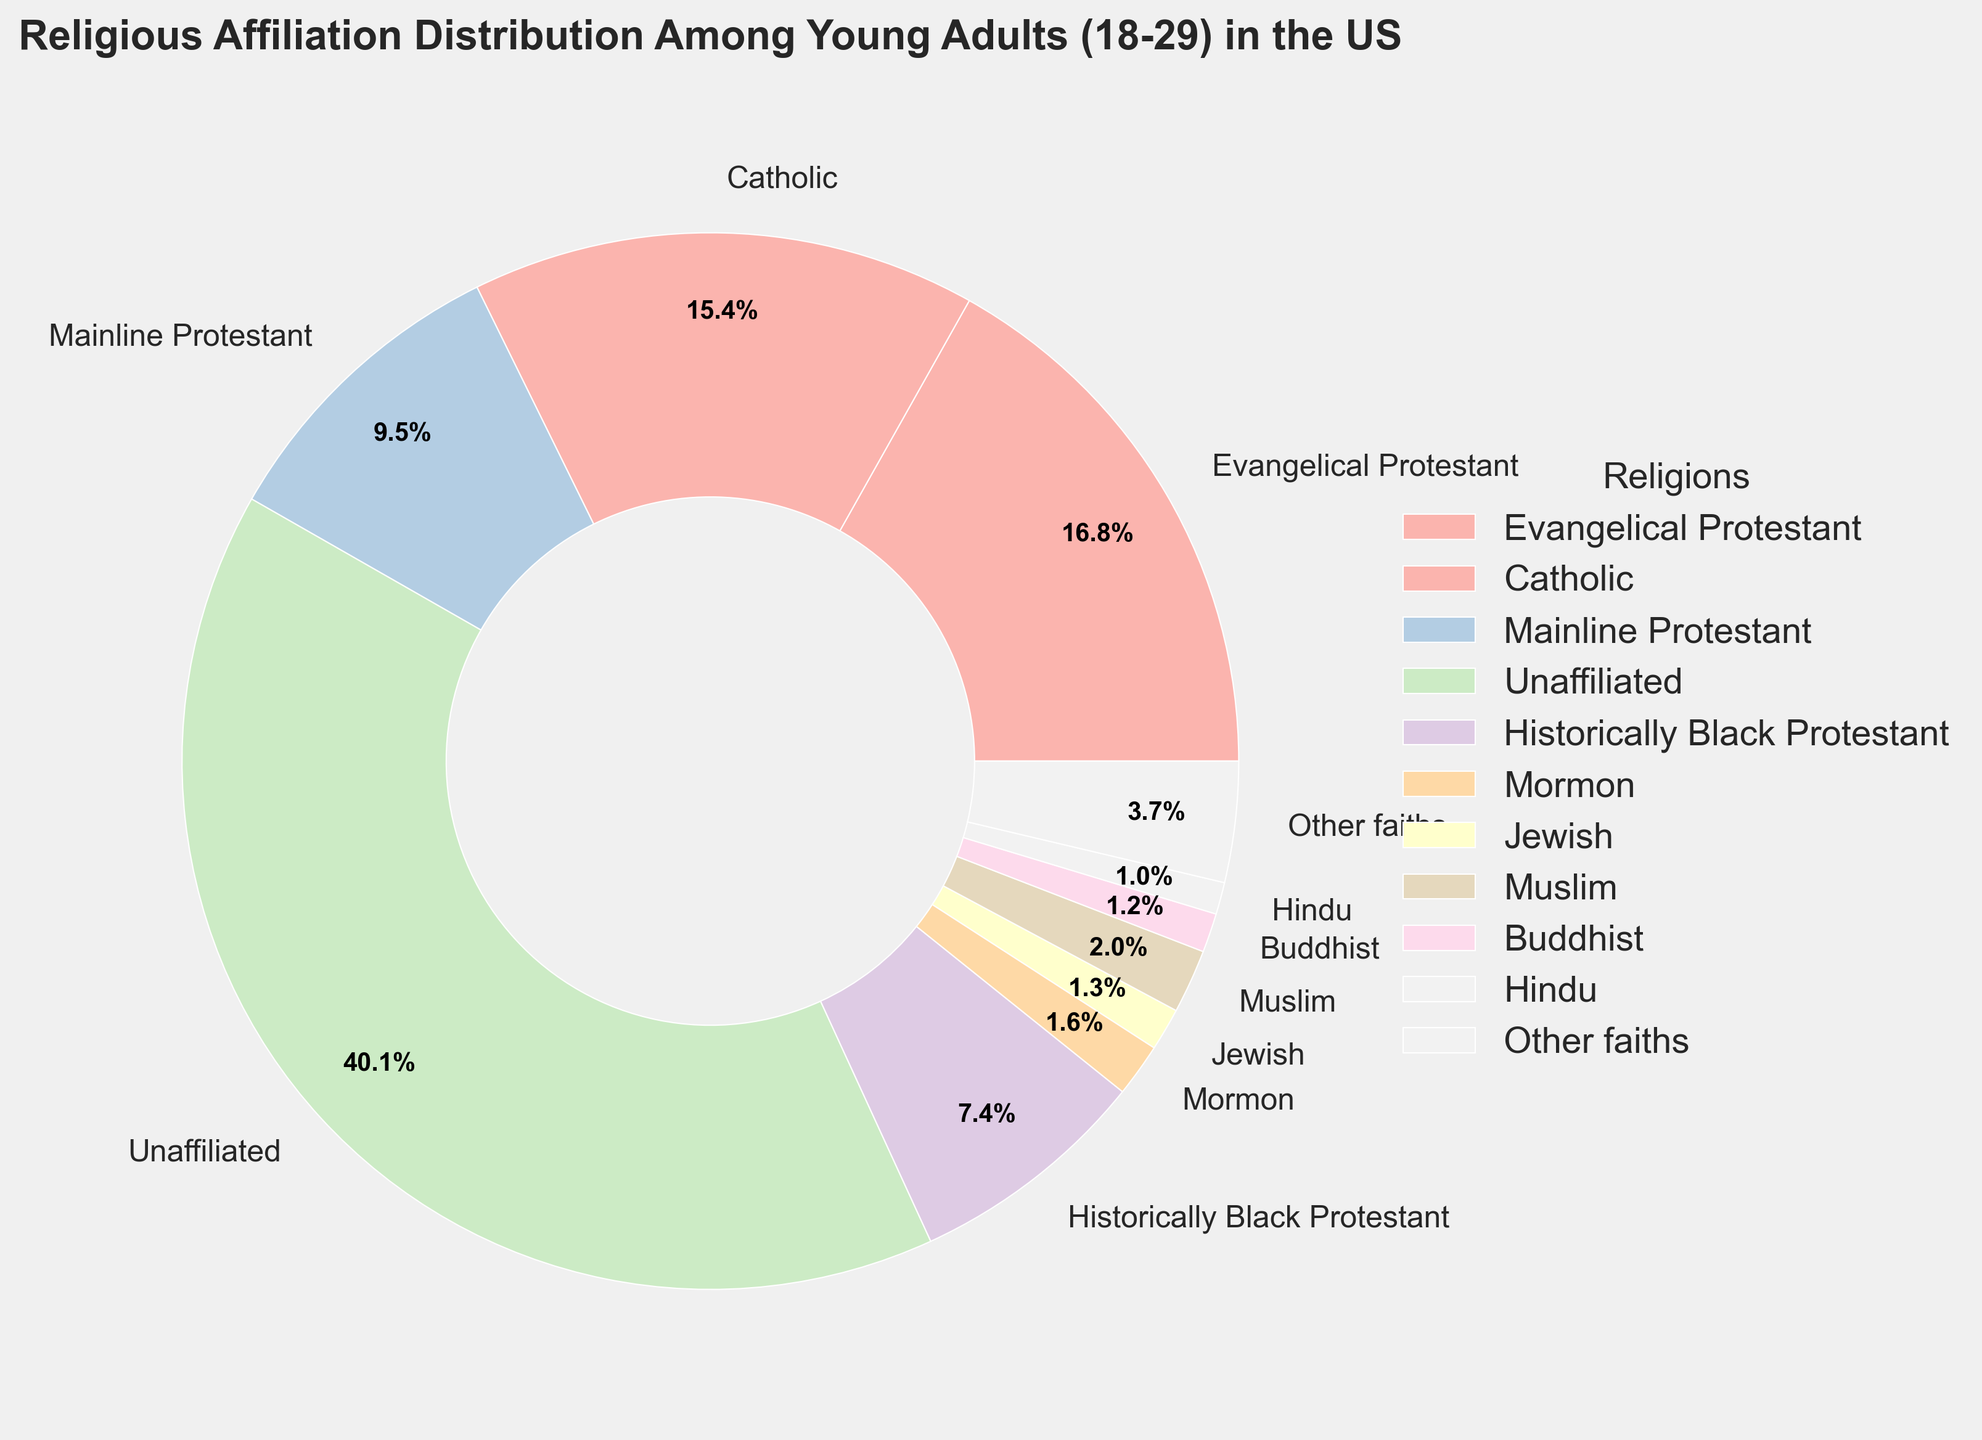What's the title of the subplot? The title is usually positioned at the top of the figure and provides an overview of the data being represented. In this case, it is "Religious Affiliation Distribution Among Young Adults (18-29) in the US".
Answer: "Religious Affiliation Distribution Among Young Adults (18-29) in the US" Which religious affiliation has the largest percentage? To find the largest percentage, we compare the percentage values of each religion shown in the chart. Unaffiliated has the highest percentage at 36.9%.
Answer: Unaffiliated What is the combined percentage of Evangelical Protestant and Mainline Protestant? Add the percentages of Evangelical Protestant (15.5%) and Mainline Protestant (8.7%). 15.5 + 8.7 = 24.2%.
Answer: 24.2% What percentage of young adults are affiliated with non-Christian religions (Jewish, Muslim, Buddhist, Hindu, Other faiths)? Sum the percentages of Jewish (1.2%), Muslim (1.8%), Buddhist (1.1%), Hindu (0.9%), and Other faiths (3.4%). 1.2 + 1.8 + 1.1 + 0.9 + 3.4 = 8.4%.
Answer: 8.4% Which two religious groups have the smallest percentages? Compare all the groups and identify the ones with the smallest values. Hindu (0.9%) and Buddhist (1.1%) have the smallest percentages.
Answer: Hindu and Buddhist Are there more young adults who are Catholic or those who are Mainline Protestant? Compare the percentages of Catholics (14.2%) and Mainline Protestants (8.7%). 14.2 is greater than 8.7.
Answer: Catholic How does the percentage of Historically Black Protestants compare to Mormons? Compare the percentages of Historically Black Protestants (6.8%) and Mormons (1.5%). 6.8 is greater than 1.5.
Answer: Historically Black Protestants have a higher percentage What is the average percentage of all the religious groups excluding 'Unaffiliated'? First, sum the percentages of all groups excluding 'Unaffiliated'. (15.5 + 14.2 + 8.7 + 6.8 + 1.5 + 1.2 + 1.8 + 1.1 + 0.9 + 3.4) = 55.1%. Then, divide by the number of these groups (10). 55.1 / 10 = 5.51%.
Answer: 5.51% Which religious group has a percentage closest to the average percentage (excluding 'Unaffiliated')? Calculate the average percentage excluding 'Unaffiliated' (5.51%). The percentage closest to this value is Historically Black Protestant (6.8%).
Answer: Historically Black Protestant 